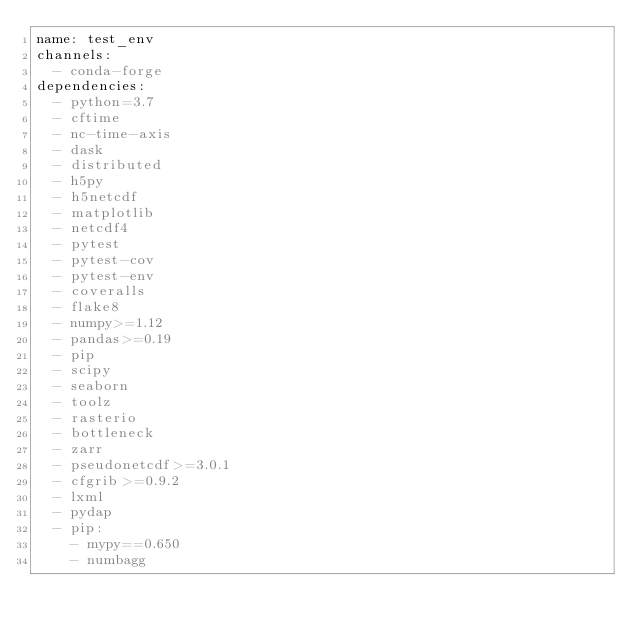Convert code to text. <code><loc_0><loc_0><loc_500><loc_500><_YAML_>name: test_env
channels:
  - conda-forge
dependencies:
  - python=3.7
  - cftime
  - nc-time-axis
  - dask
  - distributed
  - h5py
  - h5netcdf
  - matplotlib
  - netcdf4
  - pytest
  - pytest-cov
  - pytest-env
  - coveralls
  - flake8
  - numpy>=1.12
  - pandas>=0.19
  - pip
  - scipy
  - seaborn
  - toolz
  - rasterio
  - bottleneck
  - zarr
  - pseudonetcdf>=3.0.1
  - cfgrib>=0.9.2
  - lxml
  - pydap
  - pip:
    - mypy==0.650
    - numbagg
</code> 